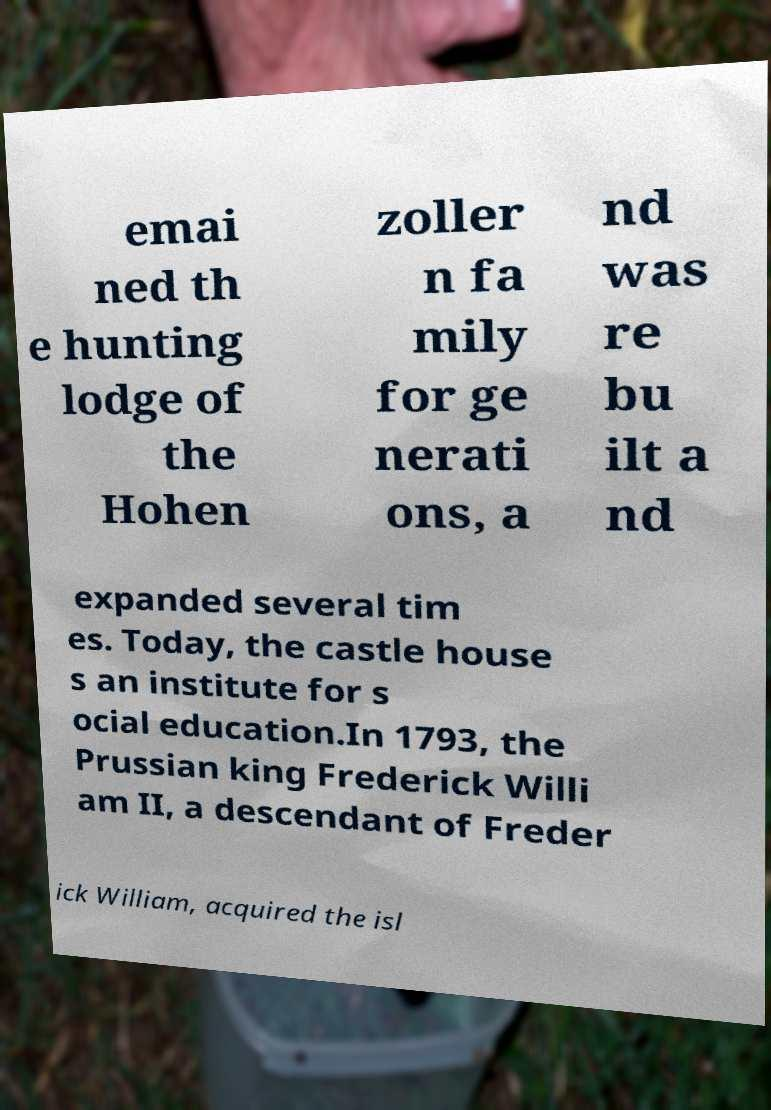Can you accurately transcribe the text from the provided image for me? emai ned th e hunting lodge of the Hohen zoller n fa mily for ge nerati ons, a nd was re bu ilt a nd expanded several tim es. Today, the castle house s an institute for s ocial education.In 1793, the Prussian king Frederick Willi am II, a descendant of Freder ick William, acquired the isl 